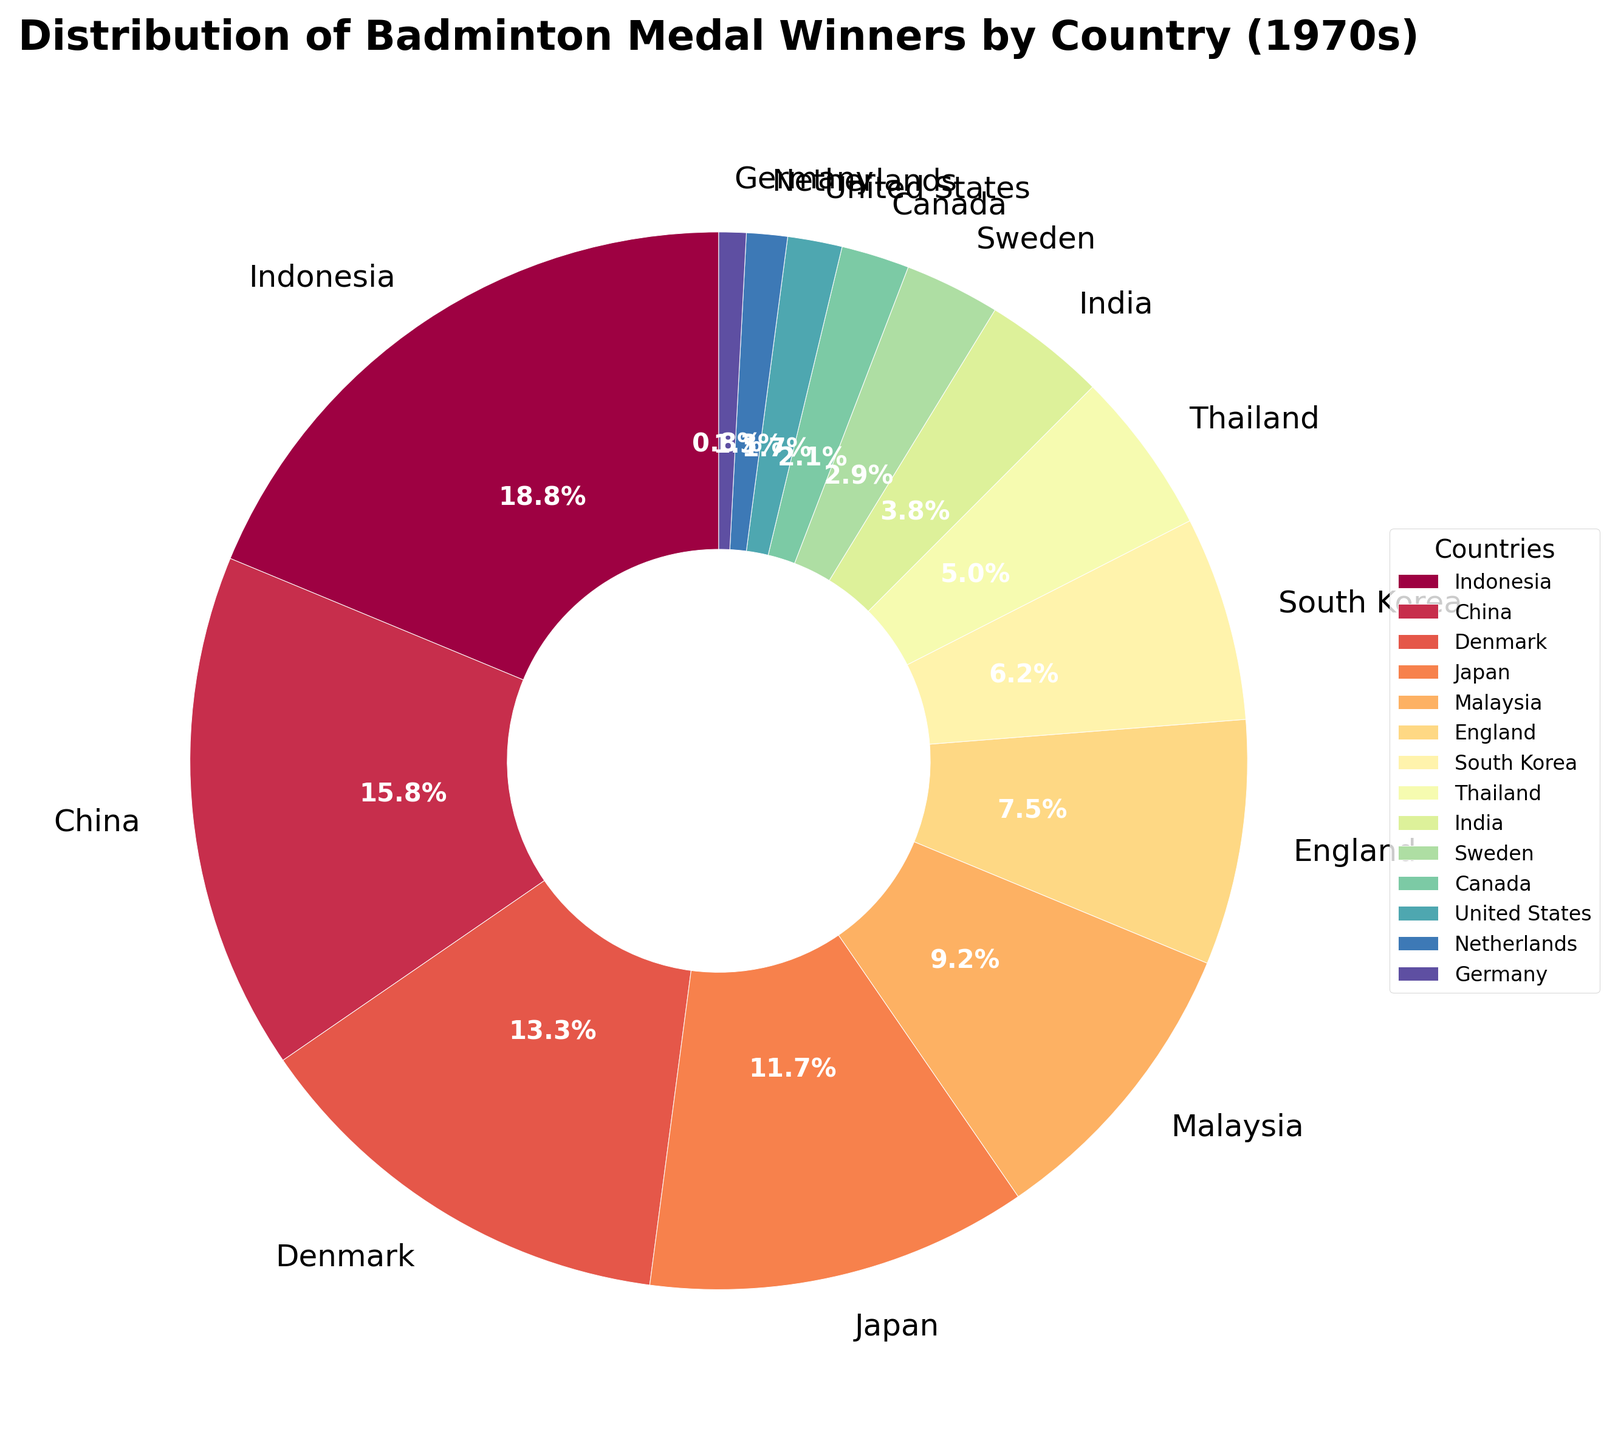What percentage of medals did Indonesia win? Indonesia's slice of the pie chart is labeled with 45 medals. The pie chart segments indicate Indonesia holds 30.8% of the total medals.
Answer: 30.8% Which country won more medals: China or Denmark? By examining the slices labeled for China and Denmark, China won 38 medals, and Denmark won 32 medals. Therefore, China won more medals.
Answer: China How many more medals did Malaysia win compared to the United States? Malaysia's slice is labeled with 22 medals, and the United States' slice is labeled with 4 medals. The difference is 22 - 4 = 18 medals.
Answer: 18 Which countries won fewer medals than Thailand? Thailand's slice is labeled with 12 medals. Countries with fewer medals are India (9), Sweden (7), Canada (5), United States (4), Netherlands (3), and Germany (2).
Answer: India, Sweden, Canada, United States, Netherlands, Germany What is the total number of medals won by the top three countries? The top three countries based on the pie chart slices are Indonesia (45), China (38), and Denmark (32). The sum is 45 + 38 + 32 = 115 medals.
Answer: 115 What is the average number of medals won by countries that won more than 20 medals? Countries with more than 20 medals: Indonesia (45), China (38), Denmark (32), Japan (28), Malaysia (22). The total is 45 + 38 + 32 + 28 + 22 = 165, and there are 5 countries. The average is 165 / 5 = 33 medals.
Answer: 33 Which country has the smallest segment in the pie chart, and how many medals did it win? The pie chart segment for Germany is the smallest, indicating it won only 2 medals.
Answer: Germany, 2 